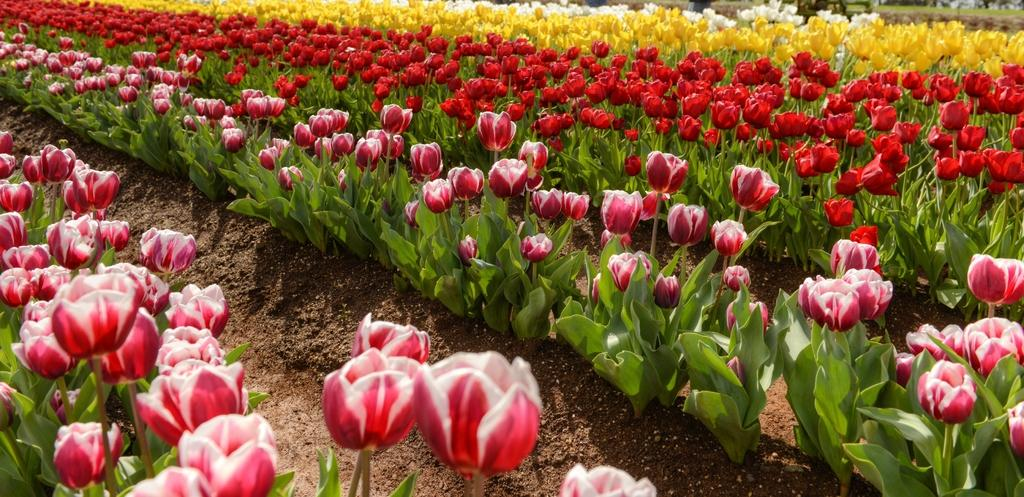What type of flowers are present in the image? There are tulip flower plants in the image. What colors can be seen among the tulip flowers? The tulip flowers have different colors, including yellow, red, pink, and white. What is the base material for the tulip flowers in the image? There is soil visible on the floor in the image, which is the base material for the tulip plants. What type of juice is being served in the image? There is no juice present in the image; it features tulip flower plants with different colors. How does the end of the tulip flower look like in the image? The image does not show the end of the tulip flowers; it only shows the flowers and their colors. 